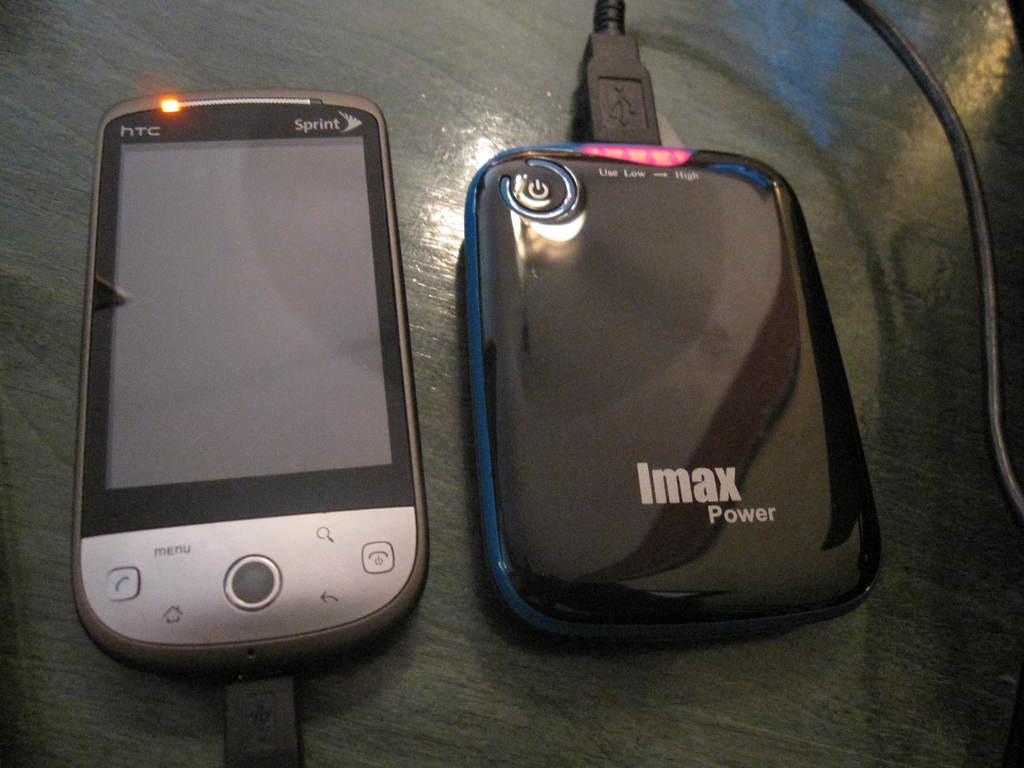<image>
Render a clear and concise summary of the photo. An HTC Sprint phone and IMAX Power charger 